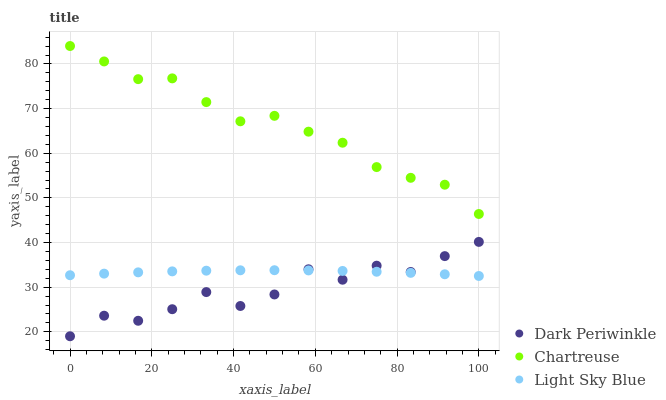Does Dark Periwinkle have the minimum area under the curve?
Answer yes or no. Yes. Does Chartreuse have the maximum area under the curve?
Answer yes or no. Yes. Does Light Sky Blue have the minimum area under the curve?
Answer yes or no. No. Does Light Sky Blue have the maximum area under the curve?
Answer yes or no. No. Is Light Sky Blue the smoothest?
Answer yes or no. Yes. Is Dark Periwinkle the roughest?
Answer yes or no. Yes. Is Dark Periwinkle the smoothest?
Answer yes or no. No. Is Light Sky Blue the roughest?
Answer yes or no. No. Does Dark Periwinkle have the lowest value?
Answer yes or no. Yes. Does Light Sky Blue have the lowest value?
Answer yes or no. No. Does Chartreuse have the highest value?
Answer yes or no. Yes. Does Dark Periwinkle have the highest value?
Answer yes or no. No. Is Light Sky Blue less than Chartreuse?
Answer yes or no. Yes. Is Chartreuse greater than Light Sky Blue?
Answer yes or no. Yes. Does Dark Periwinkle intersect Light Sky Blue?
Answer yes or no. Yes. Is Dark Periwinkle less than Light Sky Blue?
Answer yes or no. No. Is Dark Periwinkle greater than Light Sky Blue?
Answer yes or no. No. Does Light Sky Blue intersect Chartreuse?
Answer yes or no. No. 